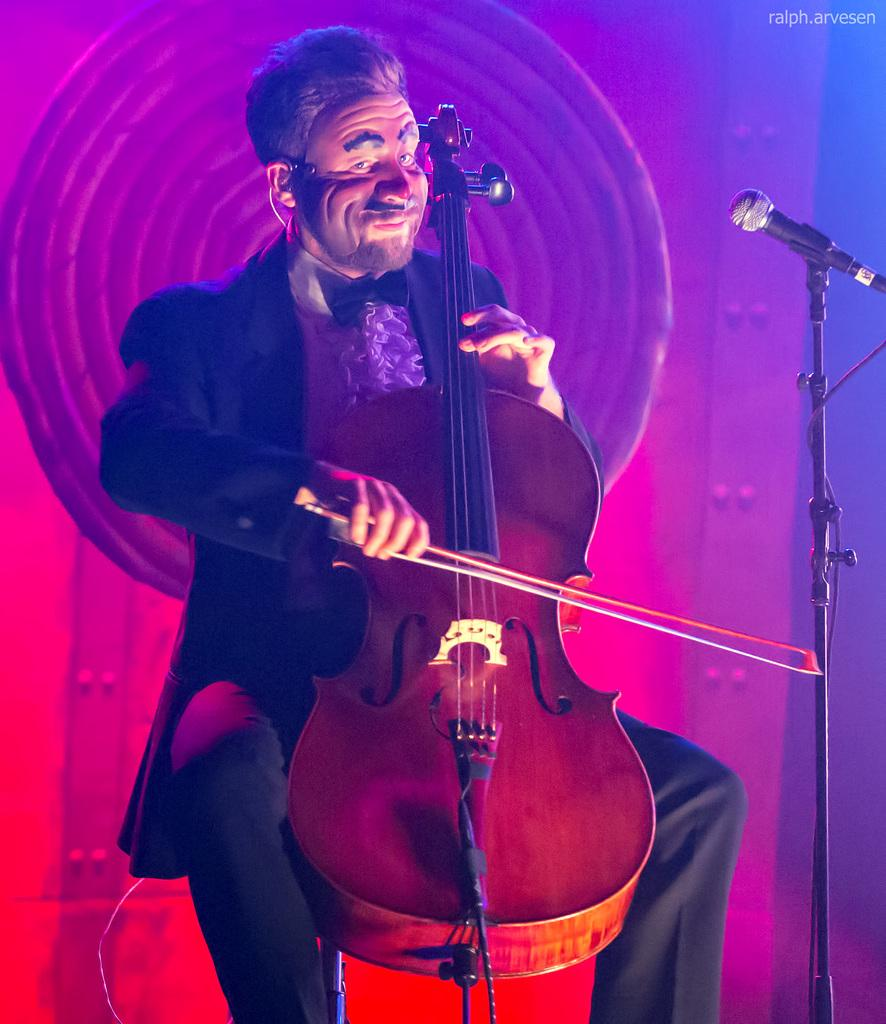Who is present in the image? There is a person in the image. What is the person wearing? The person is wearing clothes. What activity is the person engaged in? The person is playing a musical instrument. What object can be seen on the right side of the image? There is a microphone on the right side of the image. What type of feeling does the person's form convey in the image? The image does not convey a feeling or emotion, nor does it provide information about the person's form. The focus is on the person playing a musical instrument and the presence of a microphone. 